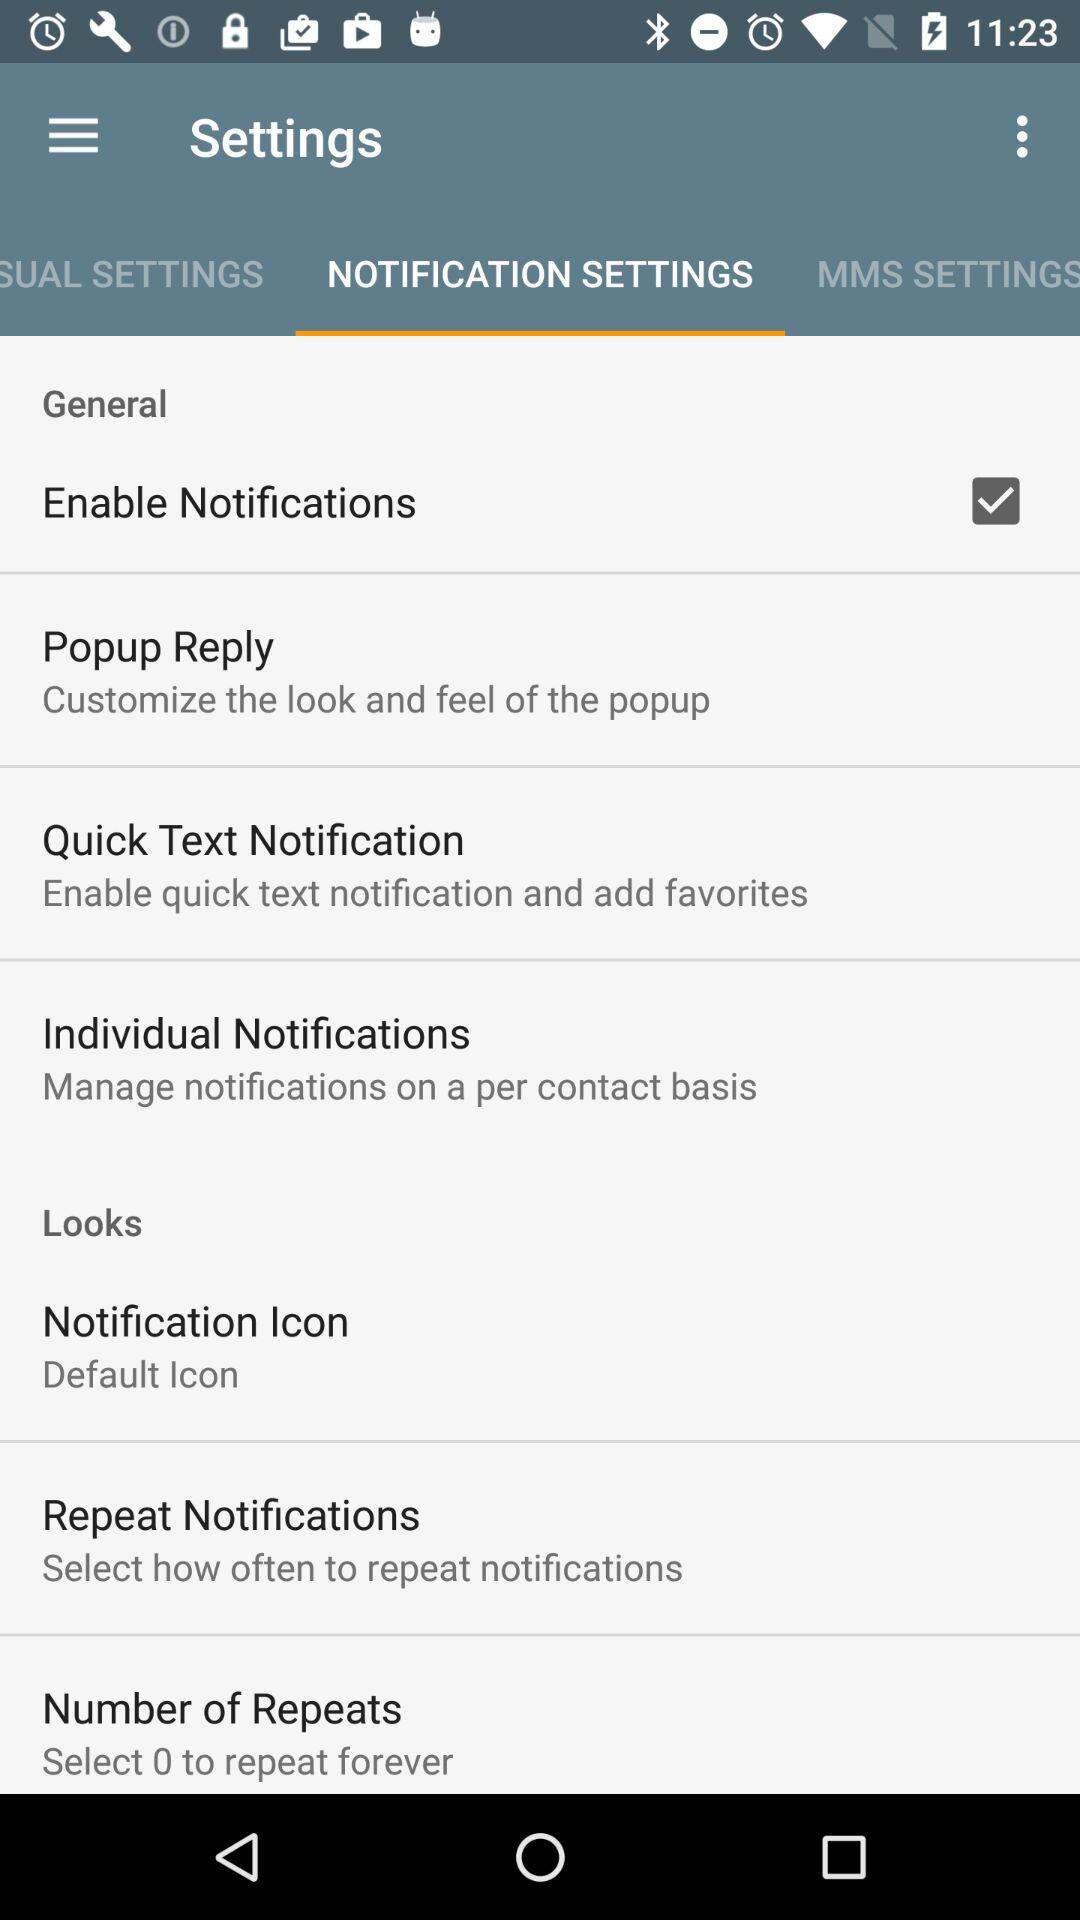What settings are selected? The selected setting is "Enable Notifications". 